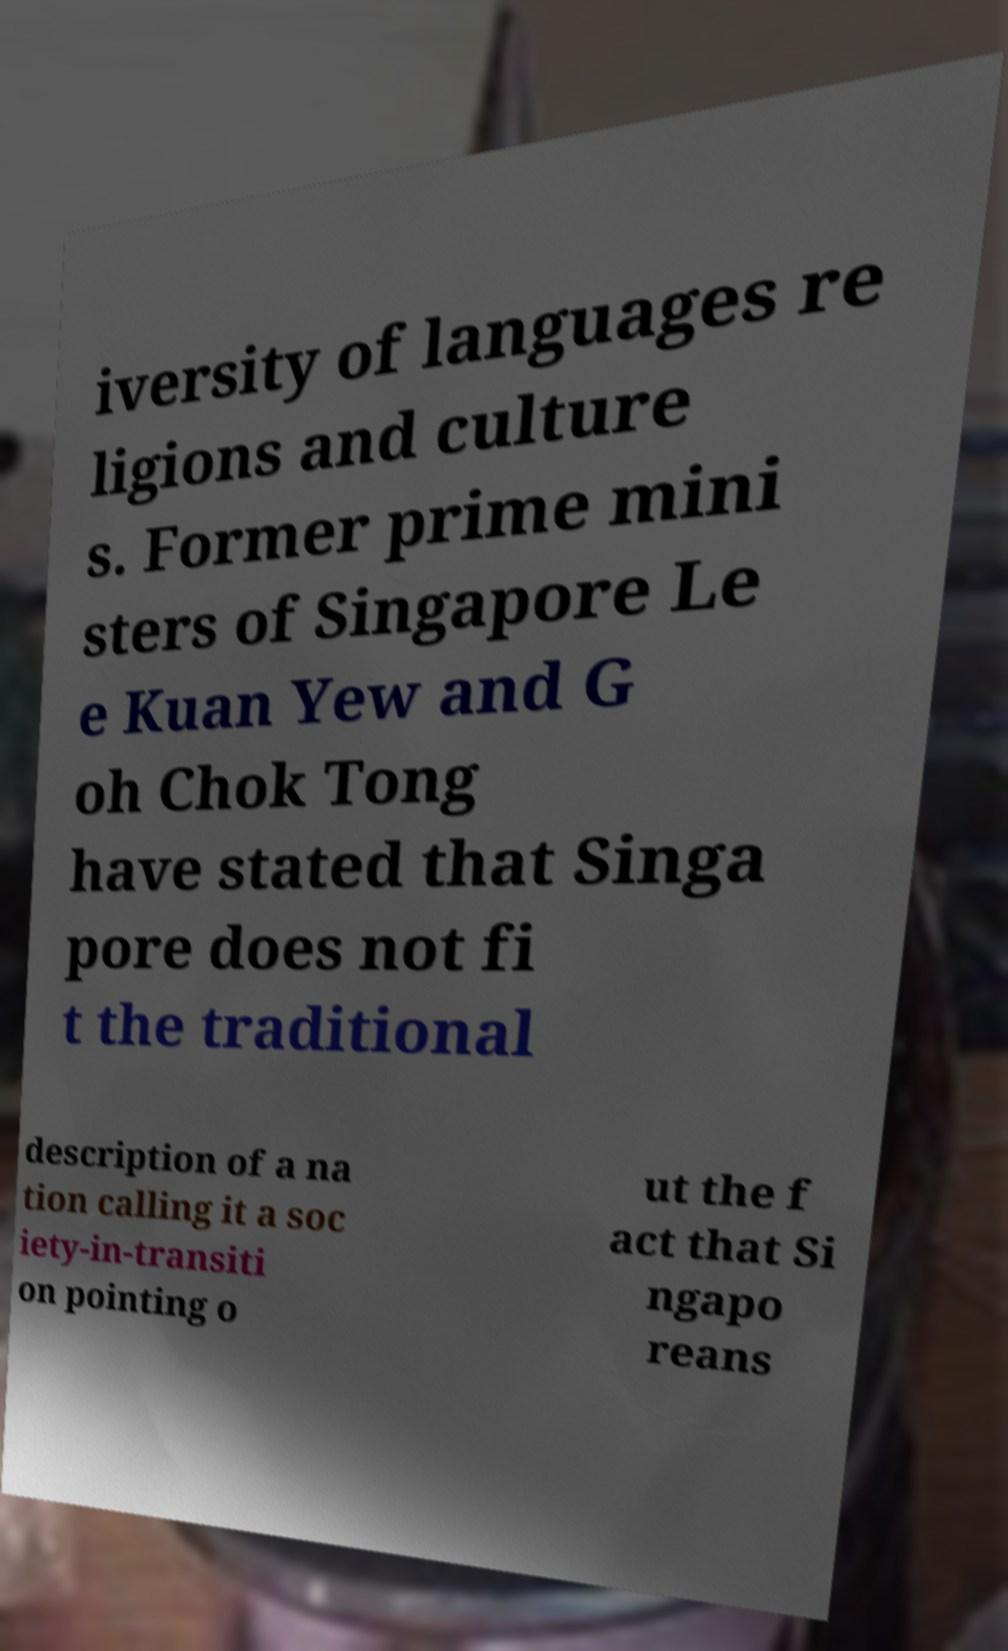There's text embedded in this image that I need extracted. Can you transcribe it verbatim? iversity of languages re ligions and culture s. Former prime mini sters of Singapore Le e Kuan Yew and G oh Chok Tong have stated that Singa pore does not fi t the traditional description of a na tion calling it a soc iety-in-transiti on pointing o ut the f act that Si ngapo reans 